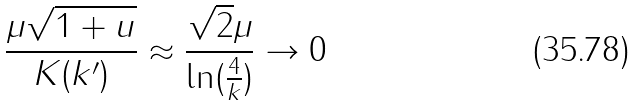<formula> <loc_0><loc_0><loc_500><loc_500>\frac { \mu \sqrt { 1 + u } } { K ( k ^ { \prime } ) } \approx \frac { \sqrt { 2 } \mu } { \ln ( \frac { 4 } { k } ) } \rightarrow 0</formula> 